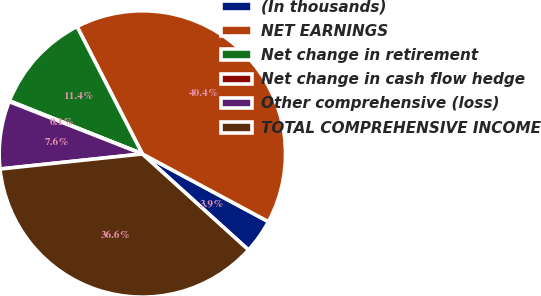<chart> <loc_0><loc_0><loc_500><loc_500><pie_chart><fcel>(In thousands)<fcel>NET EARNINGS<fcel>Net change in retirement<fcel>Net change in cash flow hedge<fcel>Other comprehensive (loss)<fcel>TOTAL COMPREHENSIVE INCOME<nl><fcel>3.86%<fcel>40.39%<fcel>11.41%<fcel>0.09%<fcel>7.64%<fcel>36.62%<nl></chart> 